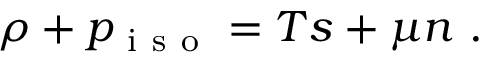Convert formula to latex. <formula><loc_0><loc_0><loc_500><loc_500>\rho + p _ { i s o } = T s + \mu n .</formula> 